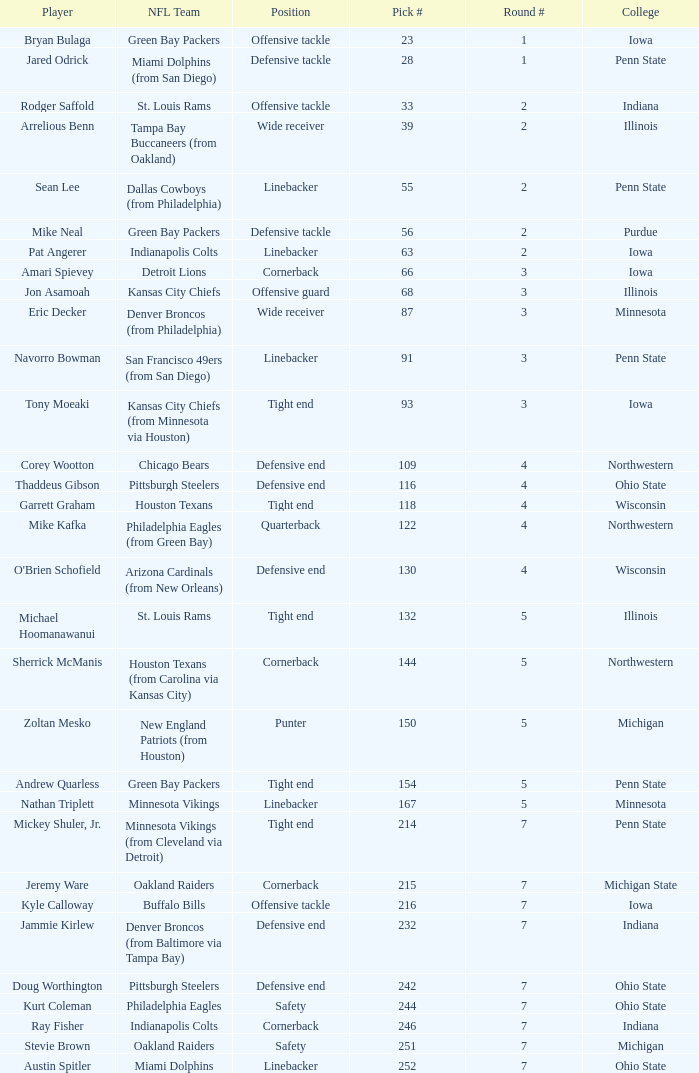What NFL team was the player with pick number 28 drafted to? Miami Dolphins (from San Diego). 